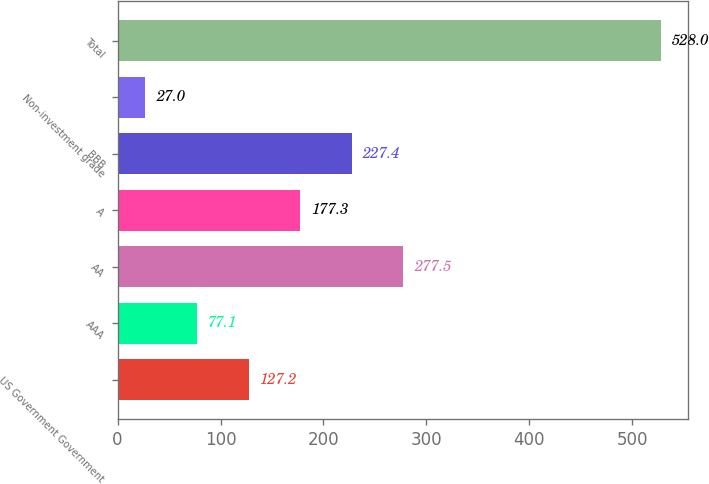<chart> <loc_0><loc_0><loc_500><loc_500><bar_chart><fcel>US Government Government<fcel>AAA<fcel>AA<fcel>A<fcel>BBB<fcel>Non-investment grade<fcel>Total<nl><fcel>127.2<fcel>77.1<fcel>277.5<fcel>177.3<fcel>227.4<fcel>27<fcel>528<nl></chart> 